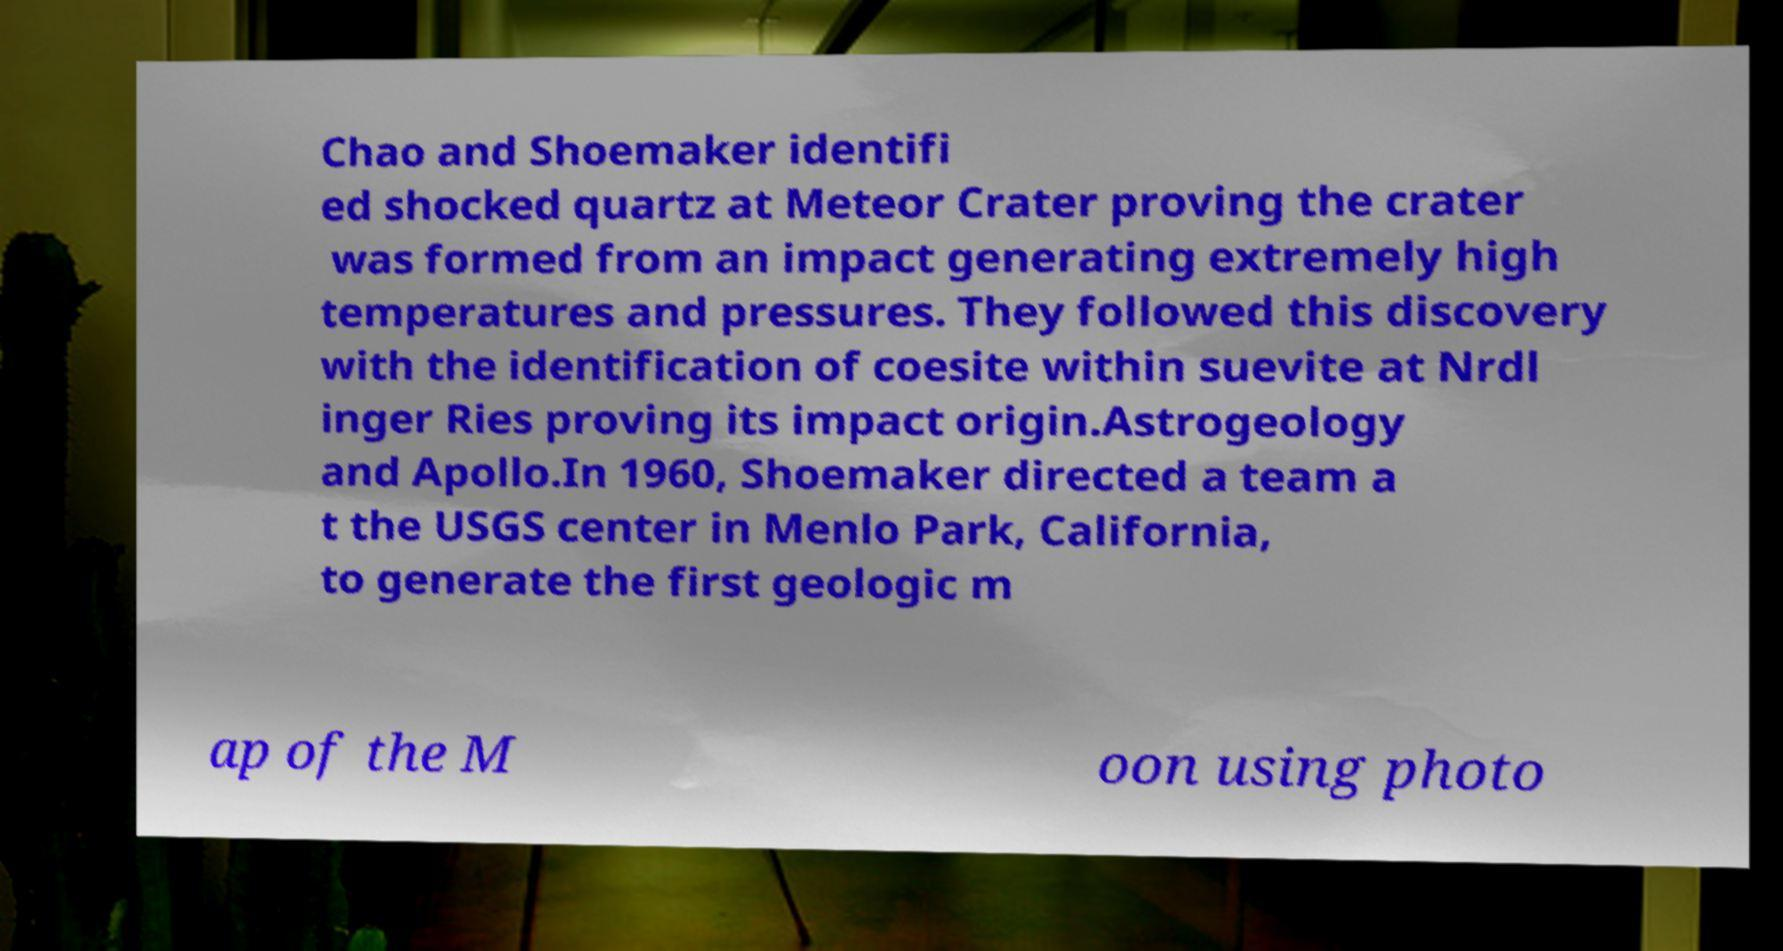Could you extract and type out the text from this image? Chao and Shoemaker identifi ed shocked quartz at Meteor Crater proving the crater was formed from an impact generating extremely high temperatures and pressures. They followed this discovery with the identification of coesite within suevite at Nrdl inger Ries proving its impact origin.Astrogeology and Apollo.In 1960, Shoemaker directed a team a t the USGS center in Menlo Park, California, to generate the first geologic m ap of the M oon using photo 